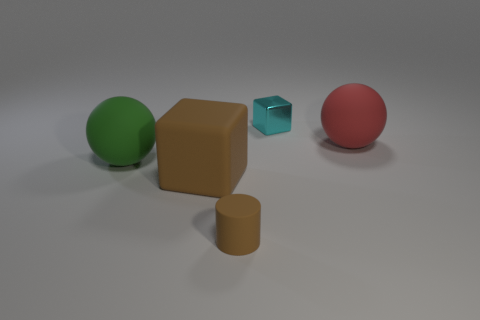Does the block that is to the left of the small brown cylinder have the same color as the small object that is in front of the small cube?
Offer a very short reply. Yes. Is there a cube that has the same color as the cylinder?
Offer a terse response. Yes. What shape is the large red object?
Your answer should be compact. Sphere. What color is the other big ball that is made of the same material as the big red ball?
Keep it short and to the point. Green. How many brown objects are either big metal cubes or tiny things?
Offer a very short reply. 1. Are there more big rubber objects than objects?
Provide a short and direct response. No. How many objects are either big green rubber spheres on the left side of the small cyan metal thing or objects on the left side of the small brown cylinder?
Offer a terse response. 2. There is a matte block that is the same size as the red object; what color is it?
Give a very brief answer. Brown. Is the material of the red object the same as the brown cube?
Provide a short and direct response. Yes. What is the material of the big ball to the right of the matte ball that is to the left of the tiny cyan block?
Keep it short and to the point. Rubber. 